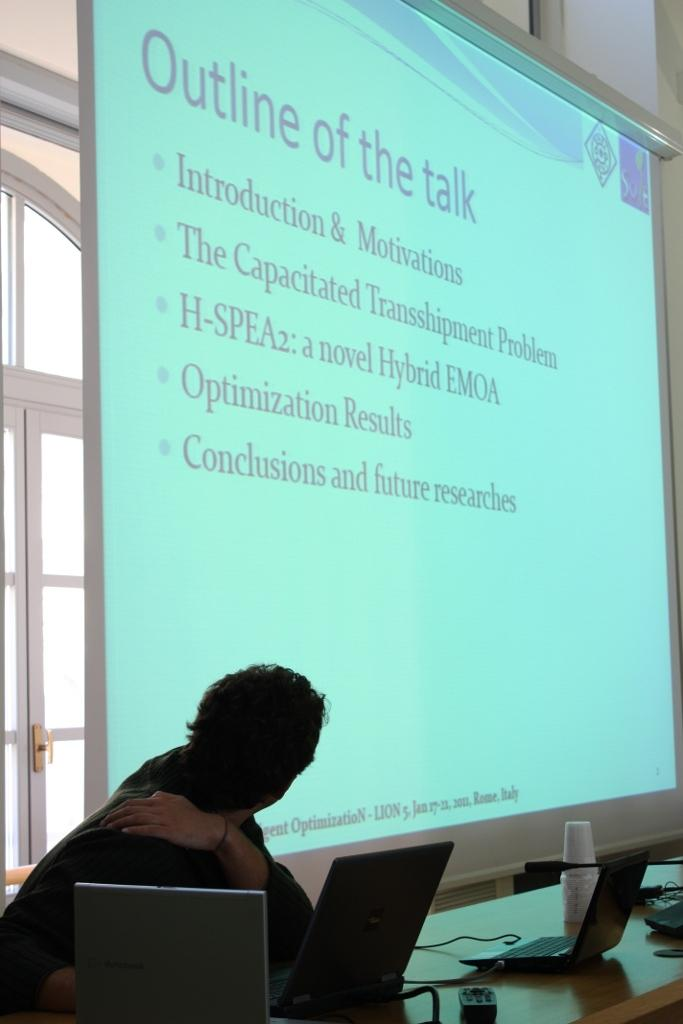Provide a one-sentence caption for the provided image. A class room with a viewing screen that has a slide titled Outline of the talk. 